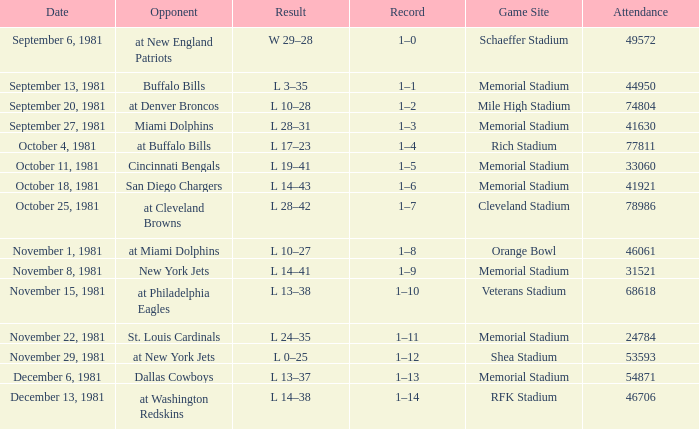On october 18, 1981, where is the location of the game? Memorial Stadium. Write the full table. {'header': ['Date', 'Opponent', 'Result', 'Record', 'Game Site', 'Attendance'], 'rows': [['September 6, 1981', 'at New England Patriots', 'W 29–28', '1–0', 'Schaeffer Stadium', '49572'], ['September 13, 1981', 'Buffalo Bills', 'L 3–35', '1–1', 'Memorial Stadium', '44950'], ['September 20, 1981', 'at Denver Broncos', 'L 10–28', '1–2', 'Mile High Stadium', '74804'], ['September 27, 1981', 'Miami Dolphins', 'L 28–31', '1–3', 'Memorial Stadium', '41630'], ['October 4, 1981', 'at Buffalo Bills', 'L 17–23', '1–4', 'Rich Stadium', '77811'], ['October 11, 1981', 'Cincinnati Bengals', 'L 19–41', '1–5', 'Memorial Stadium', '33060'], ['October 18, 1981', 'San Diego Chargers', 'L 14–43', '1–6', 'Memorial Stadium', '41921'], ['October 25, 1981', 'at Cleveland Browns', 'L 28–42', '1–7', 'Cleveland Stadium', '78986'], ['November 1, 1981', 'at Miami Dolphins', 'L 10–27', '1–8', 'Orange Bowl', '46061'], ['November 8, 1981', 'New York Jets', 'L 14–41', '1–9', 'Memorial Stadium', '31521'], ['November 15, 1981', 'at Philadelphia Eagles', 'L 13–38', '1–10', 'Veterans Stadium', '68618'], ['November 22, 1981', 'St. Louis Cardinals', 'L 24–35', '1–11', 'Memorial Stadium', '24784'], ['November 29, 1981', 'at New York Jets', 'L 0–25', '1–12', 'Shea Stadium', '53593'], ['December 6, 1981', 'Dallas Cowboys', 'L 13–37', '1–13', 'Memorial Stadium', '54871'], ['December 13, 1981', 'at Washington Redskins', 'L 14–38', '1–14', 'RFK Stadium', '46706']]} 